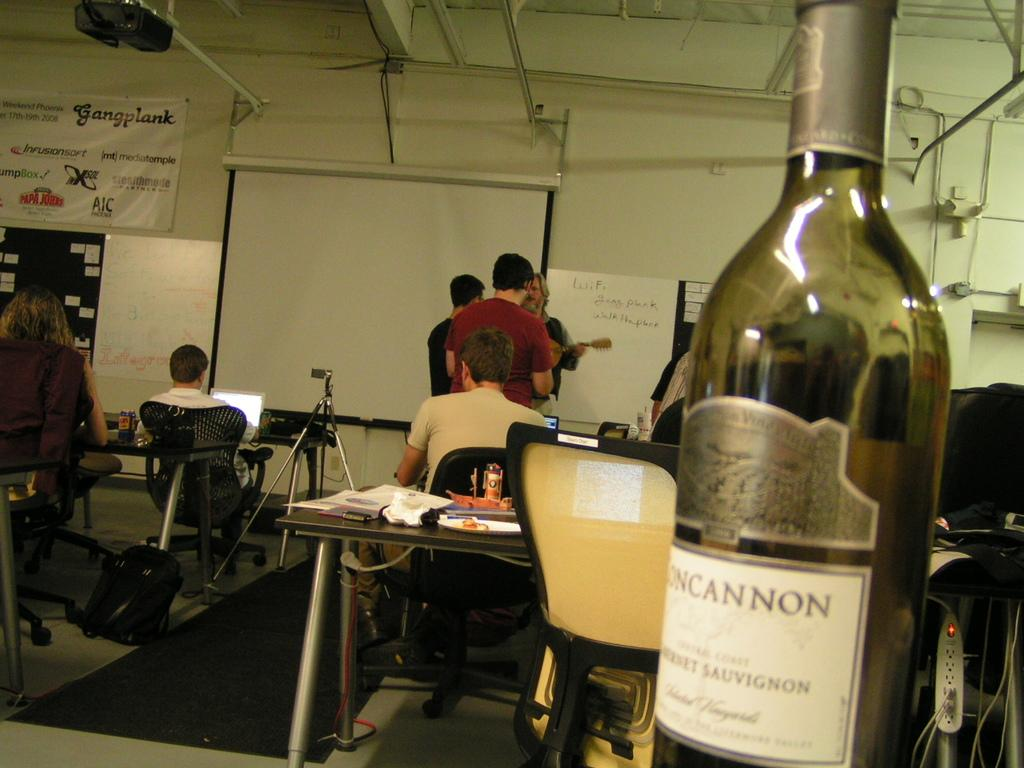<image>
Render a clear and concise summary of the photo. the word cannon that is on a bottle 